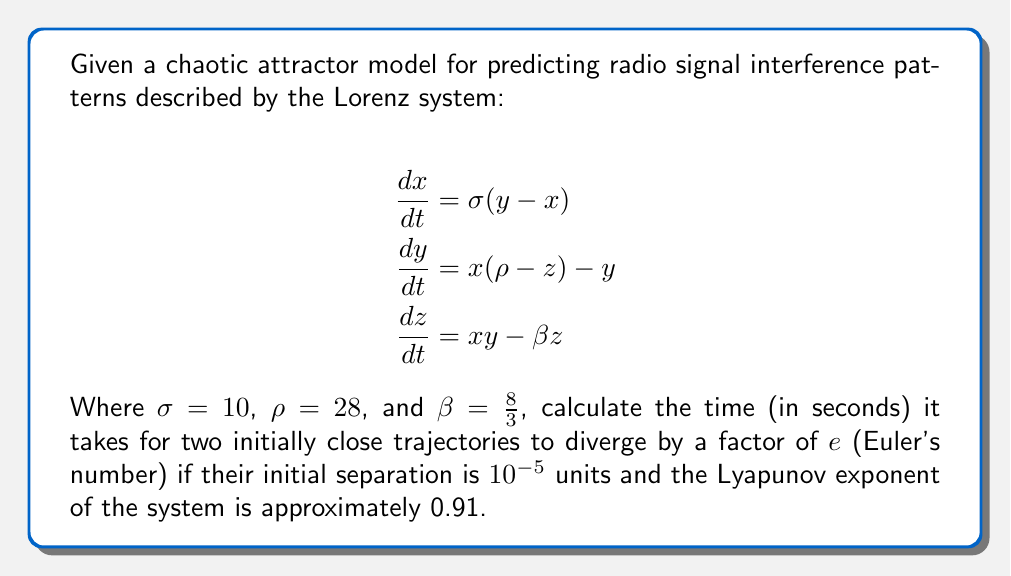Teach me how to tackle this problem. To solve this problem, we need to understand the concept of Lyapunov exponents and how they relate to the divergence of trajectories in chaotic systems. Let's break it down step-by-step:

1) The Lyapunov exponent ($\lambda$) measures the rate of separation of infinitesimally close trajectories. In this case, $\lambda \approx 0.91$.

2) The formula for the separation of trajectories over time is:

   $$d(t) = d_0 e^{\lambda t}$$

   Where $d(t)$ is the separation at time $t$, $d_0$ is the initial separation, and $\lambda$ is the Lyapunov exponent.

3) We're asked to find the time when the separation increases by a factor of $e$. This means:

   $$\frac{d(t)}{d_0} = e$$

4) Substituting this into our equation:

   $$\frac{d_0 e^{\lambda t}}{d_0} = e$$

5) The $d_0$ terms cancel out:

   $$e^{\lambda t} = e$$

6) Taking the natural log of both sides:

   $$\lambda t = 1$$

7) Solving for $t$:

   $$t = \frac{1}{\lambda}$$

8) Substituting the given Lyapunov exponent:

   $$t = \frac{1}{0.91} \approx 1.0989 \text{ seconds}$$

Therefore, it takes approximately 1.0989 seconds for the trajectories to diverge by a factor of $e$.
Answer: 1.0989 seconds 